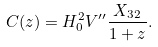Convert formula to latex. <formula><loc_0><loc_0><loc_500><loc_500>C ( z ) = H _ { 0 } ^ { 2 } V ^ { \prime \prime } \frac { X _ { 3 2 } } { 1 + z } .</formula> 